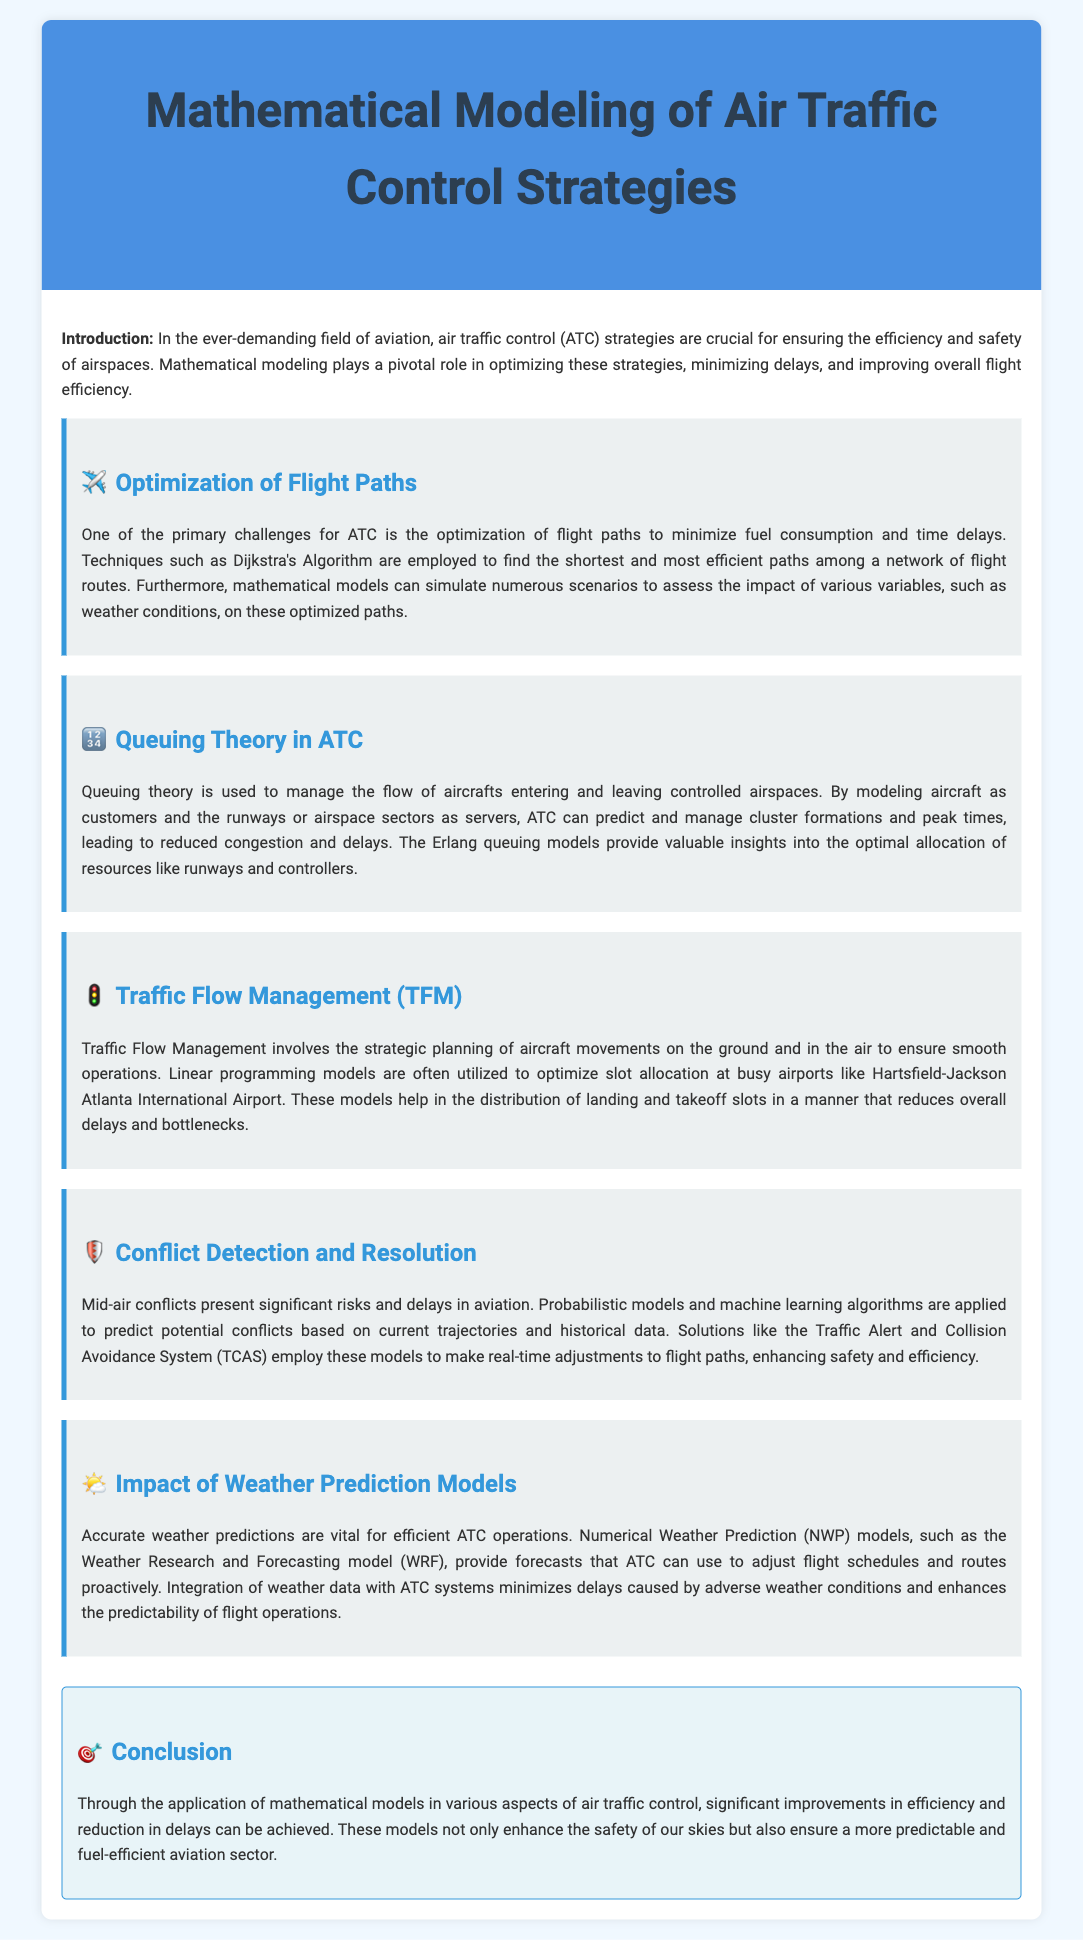What is the title of the report? The title of the report is stated in the header section at the top of the document.
Answer: Mathematical Modeling of Air Traffic Control Strategies What mathematical technique is used for optimizing flight paths? The section on flight path optimization mentions a specific algorithm used for finding efficient paths.
Answer: Dijkstra's Algorithm What does queuing theory manage in ATC? The queuing theory section explains the concept of managing flow in ATC and compares aircraft to customers.
Answer: Flow of aircrafts What does TFM stand for? The abbreviation TFM is presented in the section heading related to planning aircraft movements.
Answer: Traffic Flow Management Which forecast model is mentioned in relation to weather prediction? The section discussing the impact of weather prediction models specifies a certain model used for numerical weather predictions.
Answer: Weather Research and Forecasting model What system enhances safety and efficiency by adjusting flight paths? The conflict detection and resolution section refers to a specific system that helps prevent mid-air conflicts.
Answer: Traffic Alert and Collision Avoidance System What is the main conclusion of the report? The conclusion summarizes the overall impact of mathematical modeling on air traffic control efficiency and delays.
Answer: Significant improvements in efficiency and reduction in delays What is the primary purpose of mathematical modeling in ATC? The introduction outlines the main objective of implementing mathematical models in air traffic control strategies.
Answer: Optimizing strategies, minimizing delays, and improving efficiency 